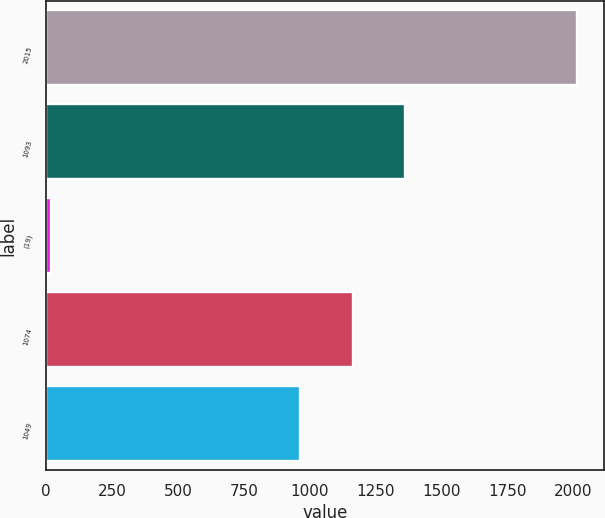<chart> <loc_0><loc_0><loc_500><loc_500><bar_chart><fcel>2015<fcel>1093<fcel>(19)<fcel>1074<fcel>1049<nl><fcel>2014<fcel>1361.4<fcel>17<fcel>1161.7<fcel>962<nl></chart> 